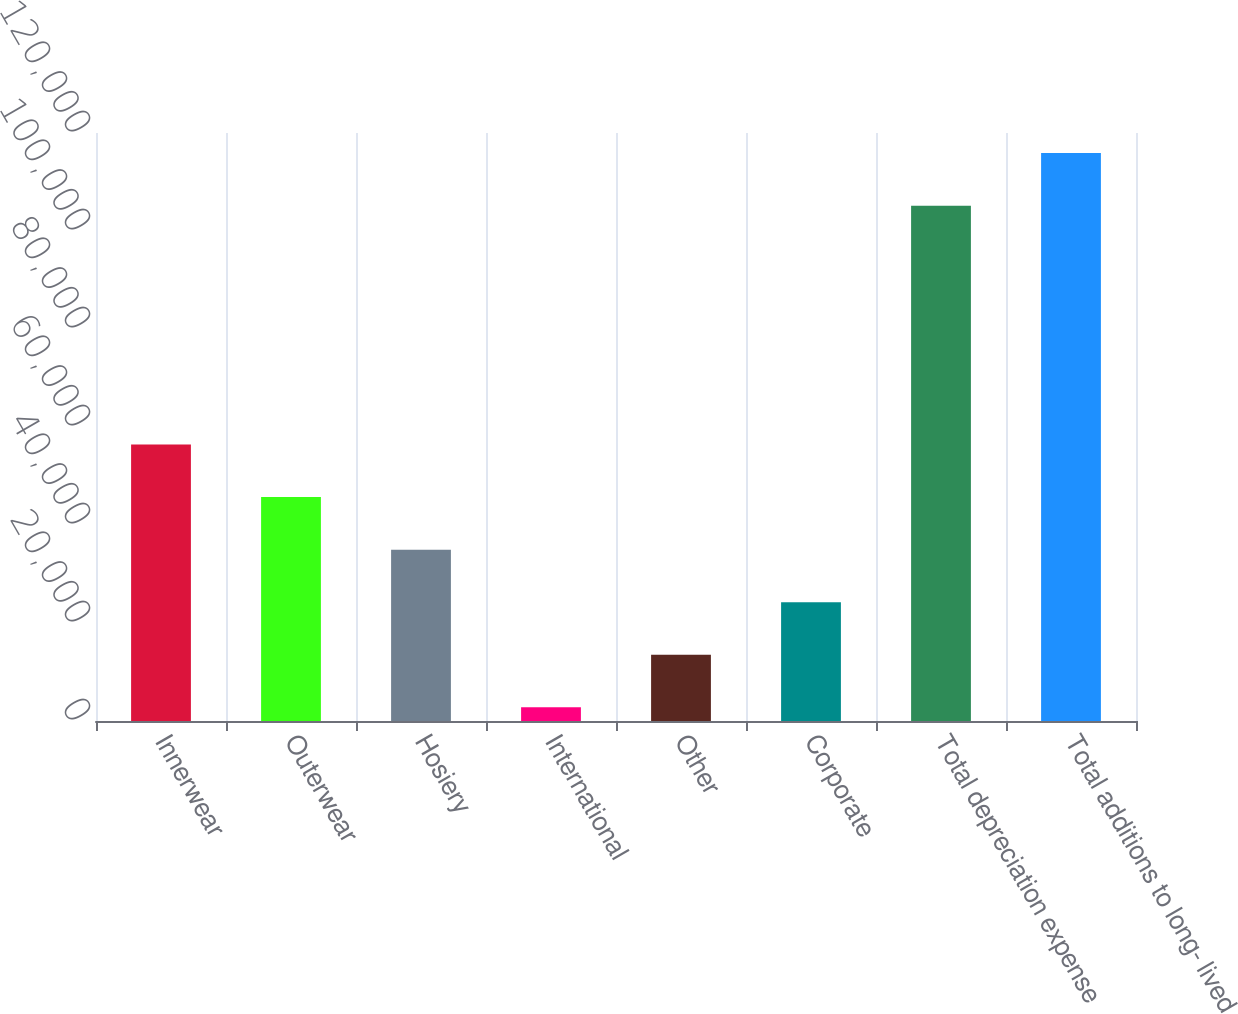Convert chart. <chart><loc_0><loc_0><loc_500><loc_500><bar_chart><fcel>Innerwear<fcel>Outerwear<fcel>Hosiery<fcel>International<fcel>Other<fcel>Corporate<fcel>Total depreciation expense<fcel>Total additions to long- lived<nl><fcel>56431<fcel>45701.4<fcel>34971.8<fcel>2783<fcel>13512.6<fcel>24242.2<fcel>105173<fcel>115903<nl></chart> 